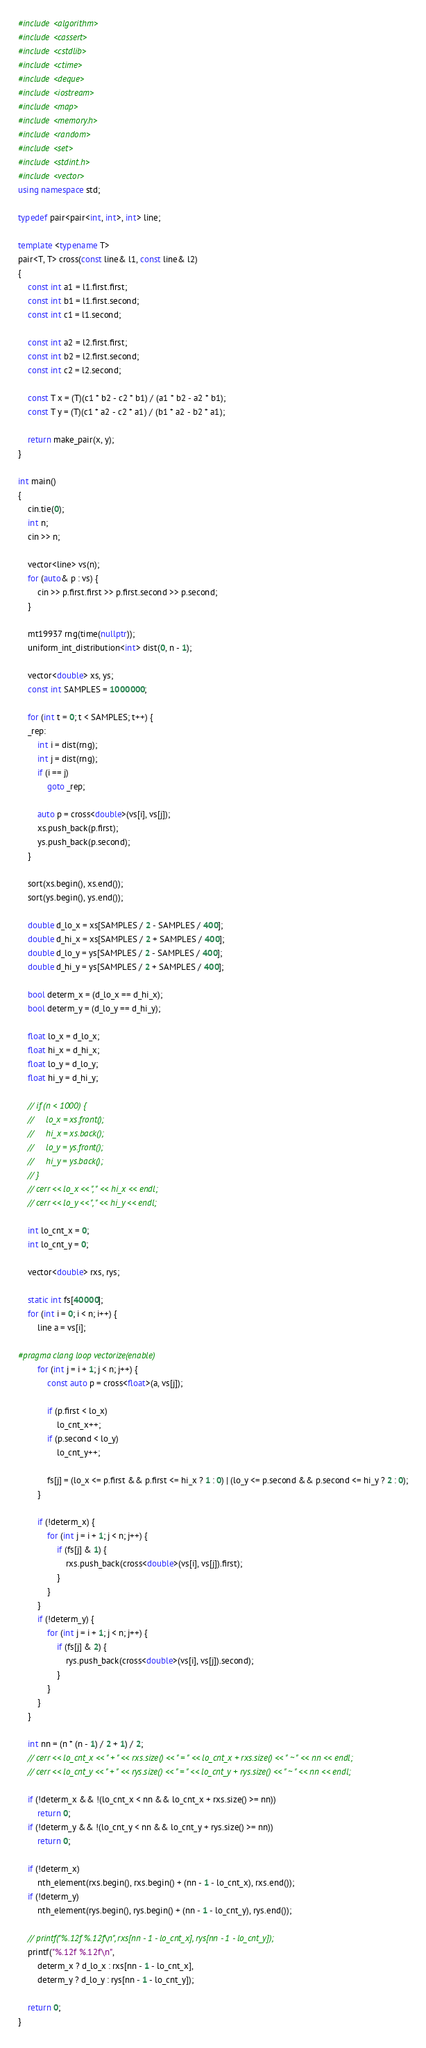<code> <loc_0><loc_0><loc_500><loc_500><_C++_>#include <algorithm>
#include <cassert>
#include <cstdlib>
#include <ctime>
#include <deque>
#include <iostream>
#include <map>
#include <memory.h>
#include <random>
#include <set>
#include <stdint.h>
#include <vector>
using namespace std;

typedef pair<pair<int, int>, int> line;

template <typename T>
pair<T, T> cross(const line& l1, const line& l2)
{
    const int a1 = l1.first.first;
    const int b1 = l1.first.second;
    const int c1 = l1.second;

    const int a2 = l2.first.first;
    const int b2 = l2.first.second;
    const int c2 = l2.second;

    const T x = (T)(c1 * b2 - c2 * b1) / (a1 * b2 - a2 * b1);
    const T y = (T)(c1 * a2 - c2 * a1) / (b1 * a2 - b2 * a1);

    return make_pair(x, y);
}

int main()
{
    cin.tie(0);
    int n;
    cin >> n;

    vector<line> vs(n);
    for (auto& p : vs) {
        cin >> p.first.first >> p.first.second >> p.second;
    }

    mt19937 rng(time(nullptr));
    uniform_int_distribution<int> dist(0, n - 1);

    vector<double> xs, ys;
    const int SAMPLES = 1000000;

    for (int t = 0; t < SAMPLES; t++) {
    _rep:
        int i = dist(rng);
        int j = dist(rng);
        if (i == j)
            goto _rep;

        auto p = cross<double>(vs[i], vs[j]);
        xs.push_back(p.first);
        ys.push_back(p.second);
    }

    sort(xs.begin(), xs.end());
    sort(ys.begin(), ys.end());

    double d_lo_x = xs[SAMPLES / 2 - SAMPLES / 400];
    double d_hi_x = xs[SAMPLES / 2 + SAMPLES / 400];
    double d_lo_y = ys[SAMPLES / 2 - SAMPLES / 400];
    double d_hi_y = ys[SAMPLES / 2 + SAMPLES / 400];

    bool determ_x = (d_lo_x == d_hi_x);
    bool determ_y = (d_lo_y == d_hi_y);

    float lo_x = d_lo_x;
    float hi_x = d_hi_x;
    float lo_y = d_lo_y;
    float hi_y = d_hi_y;

    // if (n < 1000) {
    //     lo_x = xs.front();
    //     hi_x = xs.back();
    //     lo_y = ys.front();
    //     hi_y = ys.back();
    // }
    // cerr << lo_x << ", " << hi_x << endl;
    // cerr << lo_y << ", " << hi_y << endl;

    int lo_cnt_x = 0;
    int lo_cnt_y = 0;

    vector<double> rxs, rys;

    static int fs[40000];
    for (int i = 0; i < n; i++) {
        line a = vs[i];

#pragma clang loop vectorize(enable)
        for (int j = i + 1; j < n; j++) {
            const auto p = cross<float>(a, vs[j]);

            if (p.first < lo_x)
                lo_cnt_x++;
            if (p.second < lo_y)
                lo_cnt_y++;

            fs[j] = (lo_x <= p.first && p.first <= hi_x ? 1 : 0) | (lo_y <= p.second && p.second <= hi_y ? 2 : 0);
        }

        if (!determ_x) {
            for (int j = i + 1; j < n; j++) {
                if (fs[j] & 1) {
                    rxs.push_back(cross<double>(vs[i], vs[j]).first);
                }
            }
        }
        if (!determ_y) {
            for (int j = i + 1; j < n; j++) {
                if (fs[j] & 2) {
                    rys.push_back(cross<double>(vs[i], vs[j]).second);
                }
            }
        }
    }

    int nn = (n * (n - 1) / 2 + 1) / 2;
    // cerr << lo_cnt_x << " + " << rxs.size() << " = " << lo_cnt_x + rxs.size() << " ~ " << nn << endl;
    // cerr << lo_cnt_y << " + " << rys.size() << " = " << lo_cnt_y + rys.size() << " ~ " << nn << endl;

    if (!determ_x && !(lo_cnt_x < nn && lo_cnt_x + rxs.size() >= nn))
        return 0;
    if (!determ_y && !(lo_cnt_y < nn && lo_cnt_y + rys.size() >= nn))
        return 0;

    if (!determ_x)
        nth_element(rxs.begin(), rxs.begin() + (nn - 1 - lo_cnt_x), rxs.end());
    if (!determ_y)
        nth_element(rys.begin(), rys.begin() + (nn - 1 - lo_cnt_y), rys.end());

    // printf("%.12f %.12f\n", rxs[nn - 1 - lo_cnt_x], rys[nn - 1 - lo_cnt_y]);
    printf("%.12f %.12f\n",
        determ_x ? d_lo_x : rxs[nn - 1 - lo_cnt_x],
        determ_y ? d_lo_y : rys[nn - 1 - lo_cnt_y]);

    return 0;
}
</code> 